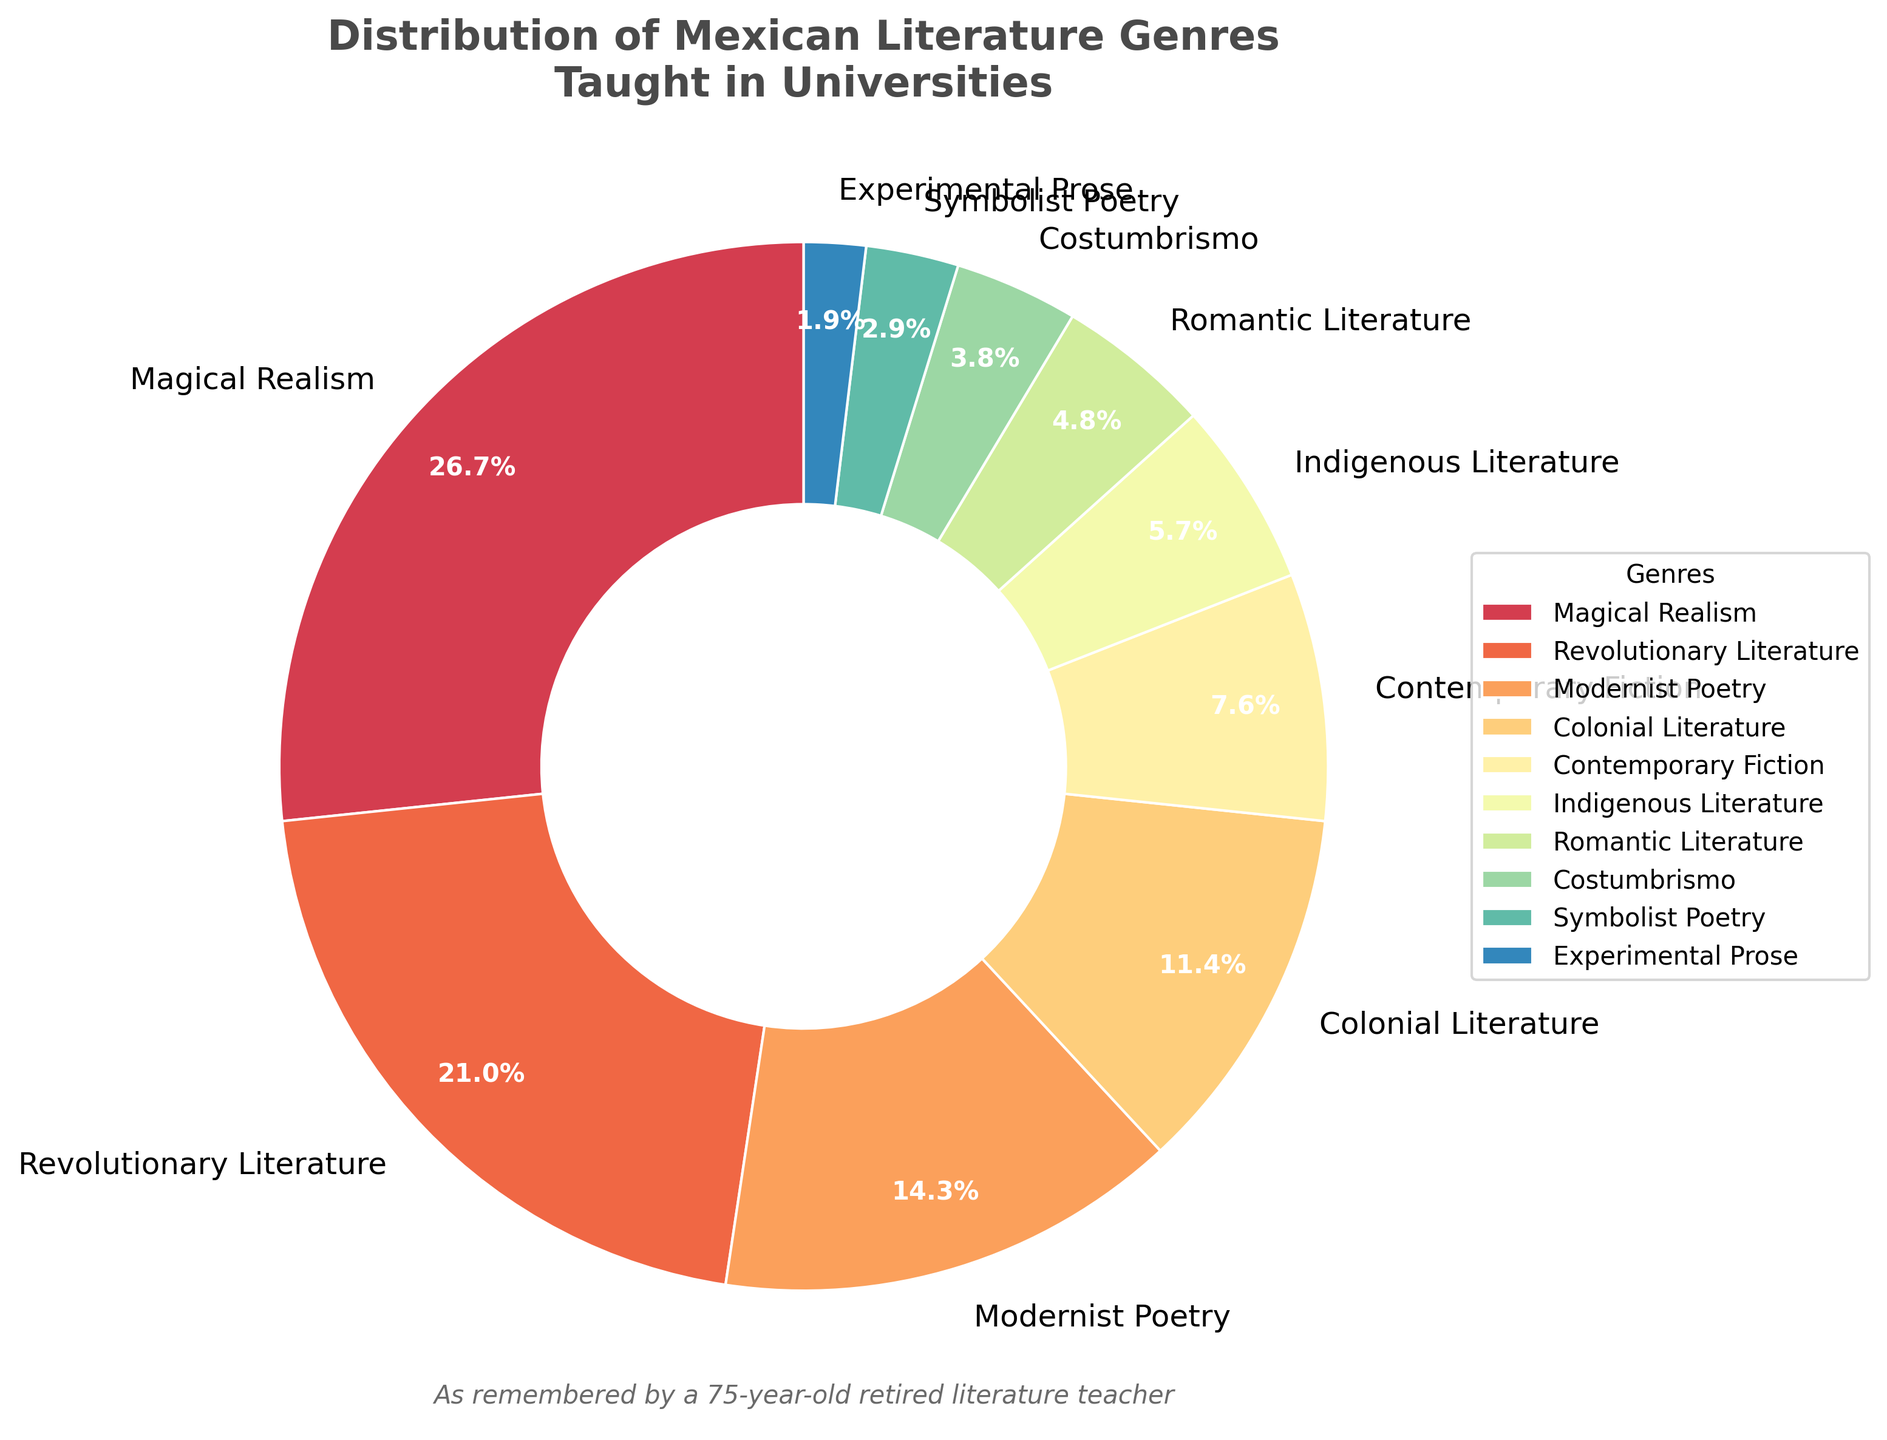What genre has the largest percentage in the distribution? The pie chart clearly shows that Magical Realism has the largest slice. By looking at the labels, we see that Magical Realism occupies 28% of the chart.
Answer: Magical Realism Which genre has a larger percentage, Revolutionary Literature or Modernist Poetry? We compare the percentages for Revolutionary Literature and Modernist Poetry. Revolutionary Literature accounts for 22% while Modernist Poetry accounts for 15%. Since 22% is greater than 15%, Revolutionary Literature has a larger percentage.
Answer: Revolutionary Literature What is the combined percentage of Colonial Literature and Contemporary Fiction? To find the combined percentage, we sum the individual percentages of Colonial Literature (12%) and Contemporary Fiction (8%). Therefore, 12% + 8% = 20%.
Answer: 20% Which genres have a percentage less than 5% and what are their combined percentages? By checking the labels, we find that Costumbrismo (4%), Symbolist Poetry (3%), and Experimental Prose (2%) each have percentages less than 5%. We then sum these percentages: 4% + 3% + 2% = 9%.
Answer: Costumbrismo, Symbolist Poetry, Experimental Prose; 9% If you combine Indigenous Literature and Romantic Literature, does their total percentage exceed that of Colonial Literature? Indigenous Literature is 6% and Romantic Literature is 5%. Adding these gives 6% + 5% = 11%, which is less than Colonial Literature's 12%. Therefore, their combined percentage does not exceed that of Colonial Literature.
Answer: No How much more percentage does Modernist Poetry have compared to Symbolist Poetry? Modernist Poetry has 15% while Symbolist Poetry has 3%. To find the difference, we subtract 3% from 15%, which results in 12%.
Answer: 12% Which genre appears the least in the distribution and what is its percentage? By observing the pie chart, we can see that the smallest slice belongs to Experimental Prose. The label indicates that it accounts for 2% of the distribution.
Answer: Experimental Prose, 2% Is the percentage of Romantic Literature greater than the sum of Indigenous Literature and Costumbrismo? We calculate the sum of Indigenous Literature (6%) and Costumbrismo (4%), which equals 10%. Romantic Literature has a percentage of 5%, which is less than 10%. Therefore, its percentage is not greater.
Answer: No What is the difference in percentage between Modernist Poetry and Contemporary Fiction? To find the difference, we subtract the percentage of Contemporary Fiction (8%) from Modernist Poetry's percentage (15%). Thus, 15% - 8% equals 7%.
Answer: 7% If you sum the percentages of the three least represented genres, does it exceed the percentage of Contemporary Fiction? The three least represented genres are Experimental Prose (2%), Symbolist Poetry (3%), and Costumbrismo (4%). Summing these gives 2% + 3% + 4% = 9%, which is greater than Contemporary Fiction's 8%.
Answer: Yes 